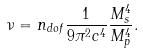<formula> <loc_0><loc_0><loc_500><loc_500>\nu = n _ { d o f } \frac { 1 } { 9 \pi ^ { 2 } c ^ { 4 } } \frac { M _ { s } ^ { 4 } } { M _ { p } ^ { 4 } } .</formula> 